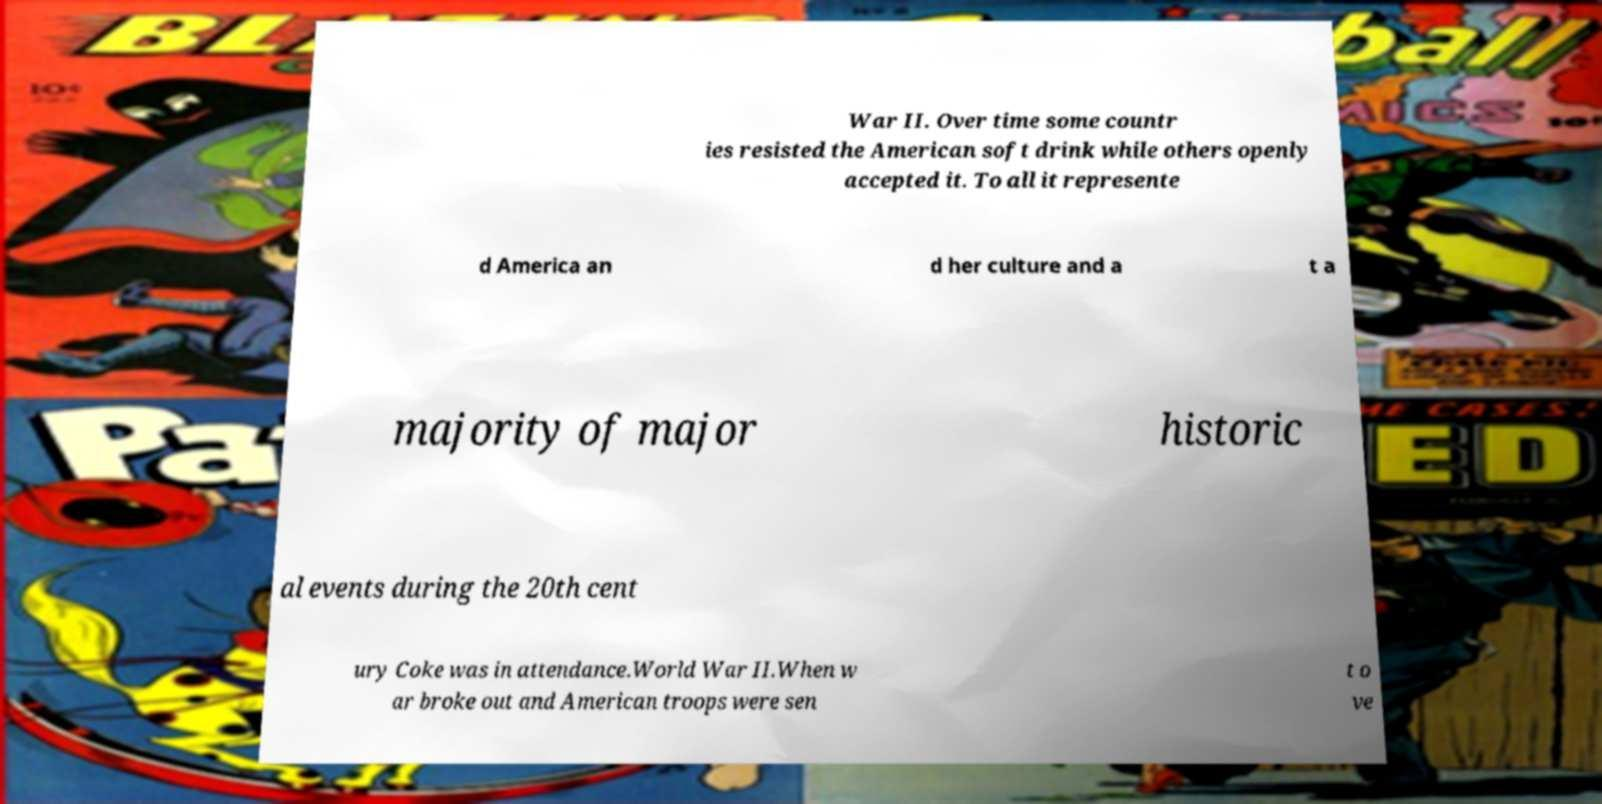Could you extract and type out the text from this image? War II. Over time some countr ies resisted the American soft drink while others openly accepted it. To all it represente d America an d her culture and a t a majority of major historic al events during the 20th cent ury Coke was in attendance.World War II.When w ar broke out and American troops were sen t o ve 